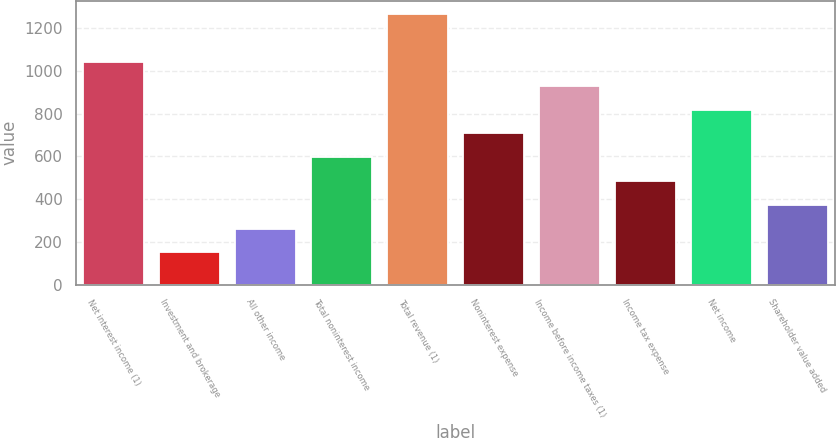<chart> <loc_0><loc_0><loc_500><loc_500><bar_chart><fcel>Net interest income (1)<fcel>Investment and brokerage<fcel>All other income<fcel>Total noninterest income<fcel>Total revenue (1)<fcel>Noninterest expense<fcel>Income before income taxes (1)<fcel>Income tax expense<fcel>Net income<fcel>Shareholder value added<nl><fcel>1042.2<fcel>151<fcel>262.4<fcel>596.6<fcel>1265<fcel>708<fcel>930.8<fcel>485.2<fcel>819.4<fcel>373.8<nl></chart> 